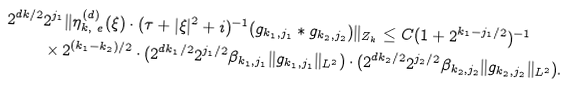<formula> <loc_0><loc_0><loc_500><loc_500>2 ^ { d k / 2 } & 2 ^ { j _ { 1 } } \| \eta _ { k , \ e } ^ { ( d ) } ( \xi ) \cdot ( \tau + | \xi | ^ { 2 } + i ) ^ { - 1 } ( g _ { k _ { 1 } , j _ { 1 } } \ast g _ { k _ { 2 } , j _ { 2 } } ) \| _ { Z _ { k } } \leq C ( 1 + 2 ^ { k _ { 1 } - j _ { 1 } / 2 } ) ^ { - 1 } \\ & \times 2 ^ { ( k _ { 1 } - k _ { 2 } ) / 2 } \cdot ( 2 ^ { d k _ { 1 } / 2 } 2 ^ { j _ { 1 } / 2 } \beta _ { k _ { 1 } , j _ { 1 } } \| g _ { k _ { 1 } , j _ { 1 } } \| _ { L ^ { 2 } } ) \cdot ( 2 ^ { d k _ { 2 } / 2 } 2 ^ { j _ { 2 } / 2 } \beta _ { k _ { 2 } , j _ { 2 } } \| g _ { k _ { 2 } , j _ { 2 } } \| _ { L ^ { 2 } } ) .</formula> 